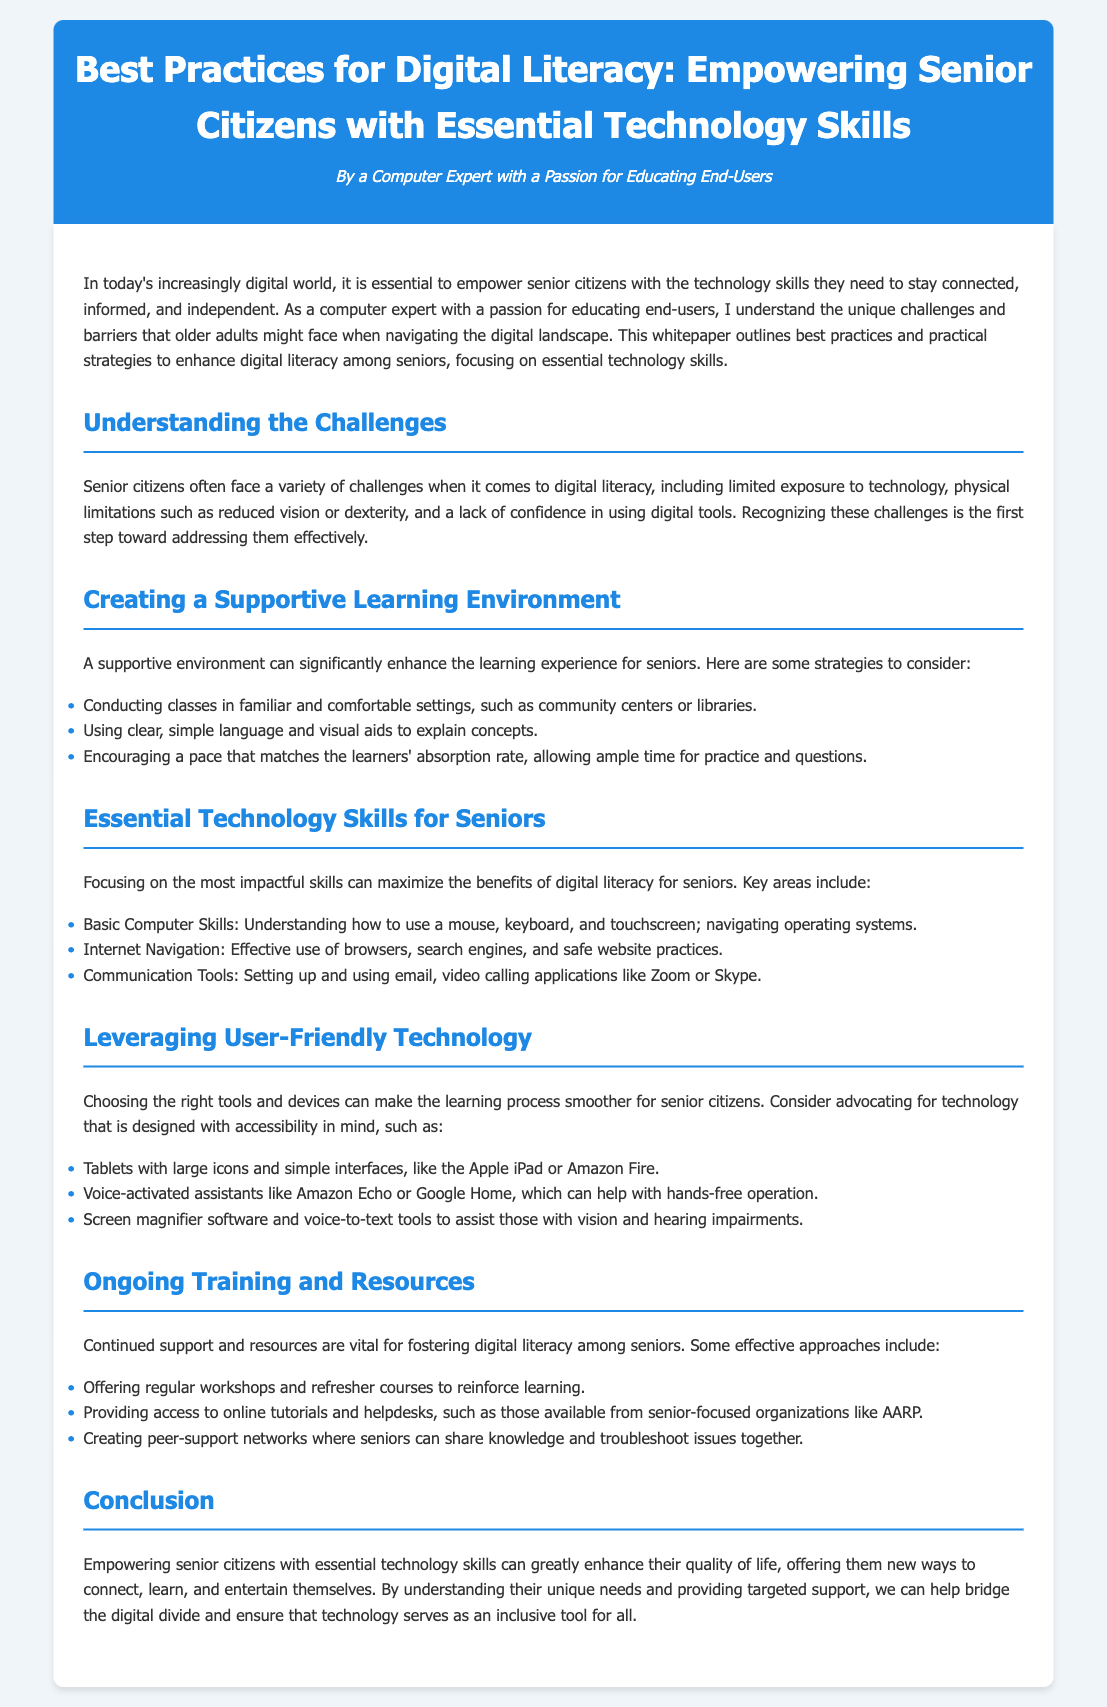What is the title of the whitepaper? The title summarizes the main focus of the document on digital literacy and seniors.
Answer: Best Practices for Digital Literacy: Empowering Senior Citizens with Essential Technology Skills Who is the author of the document? The author’s identity is mentioned in the header of the document.
Answer: A Computer Expert with a Passion for Educating End-Users What section discusses challenges faced by seniors? The document has a specific section that highlights the difficulties seniors encounter in digital literacy.
Answer: Understanding the Challenges What are some essential technology skills mentioned for seniors? The document provides key areas that seniors should focus on for digital literacy.
Answer: Basic Computer Skills, Internet Navigation, Communication Tools What type of environment is recommended for senior learning? The section provides specific suggestions for enhancing the learning experience for seniors.
Answer: Supportive Learning Environment Which technology is suggested for hands-free operation? The document lists tools designed to assist seniors with limited mobility.
Answer: Voice-activated assistants like Amazon Echo or Google Home What does the document recommend for ongoing support? The whitepaper discusses the importance of continued education in maintaining digital skills.
Answer: Regular workshops and refresher courses What is the main goal of empowering senior citizens according to the document? The conclusion summarizes the overarching aim of providing technology skills to older adults.
Answer: Enhance their quality of life 